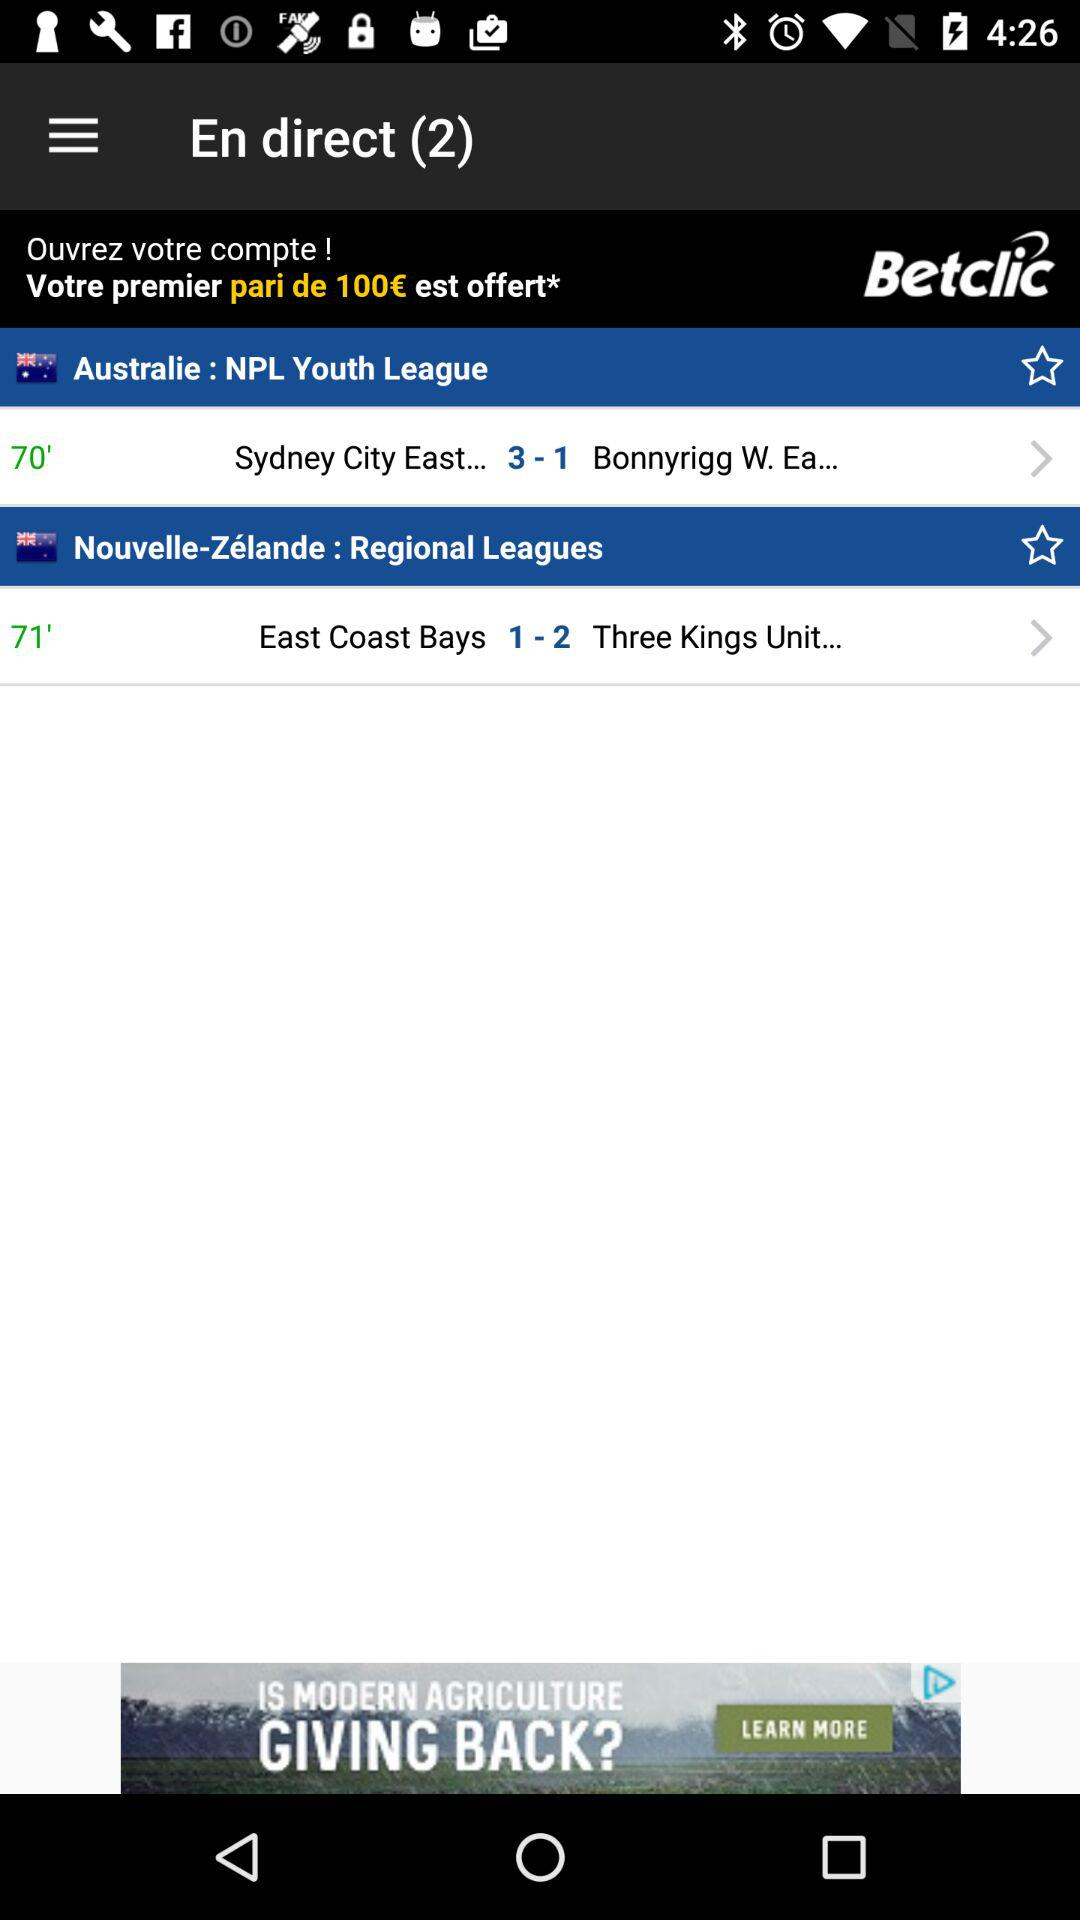How many live matches are there?
Answer the question using a single word or phrase. 2 